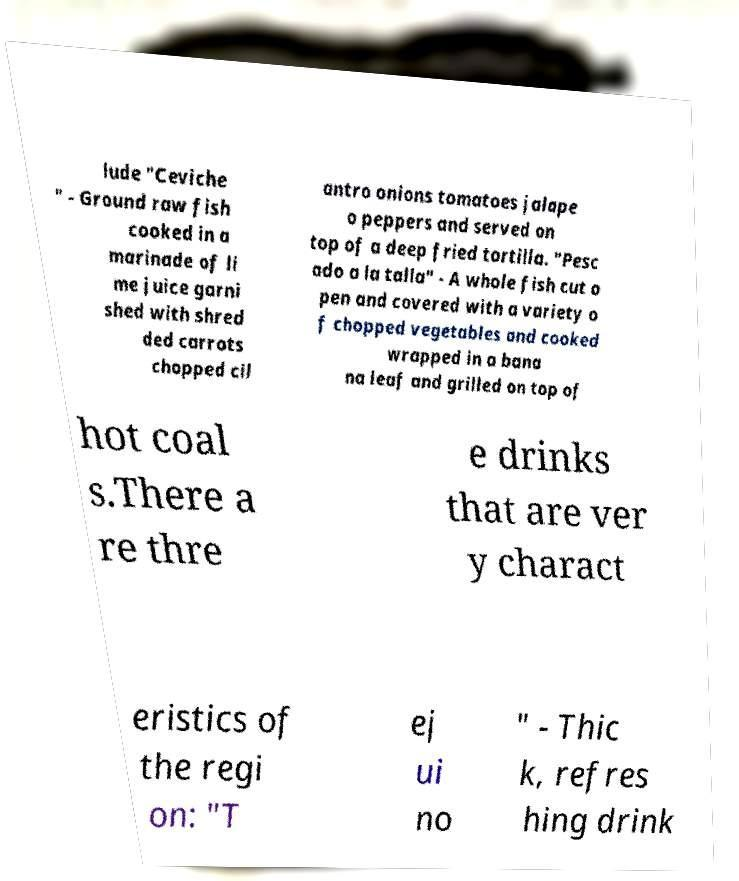Please read and relay the text visible in this image. What does it say? lude "Ceviche " - Ground raw fish cooked in a marinade of li me juice garni shed with shred ded carrots chopped cil antro onions tomatoes jalape o peppers and served on top of a deep fried tortilla. "Pesc ado a la talla" - A whole fish cut o pen and covered with a variety o f chopped vegetables and cooked wrapped in a bana na leaf and grilled on top of hot coal s.There a re thre e drinks that are ver y charact eristics of the regi on: "T ej ui no " - Thic k, refres hing drink 